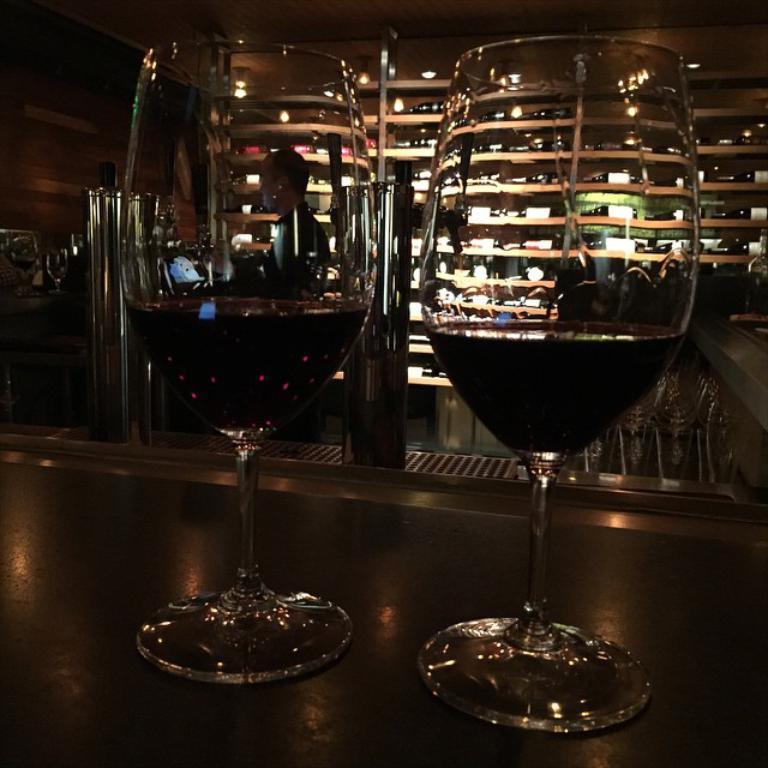Can you describe this image briefly? There are two glasses with some liquid on the table. In the background of the image there are shelf´s. There is a person. There are chairs. 